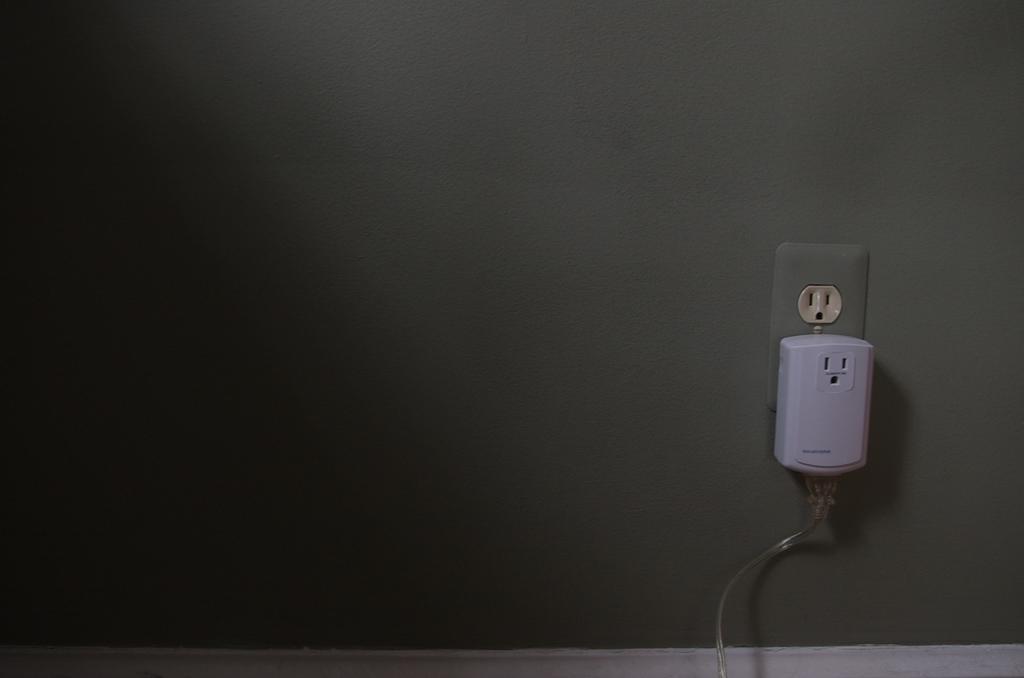Please provide a concise description of this image. In this picture we can see a wall with the sockets and on the socket there is an adapter with a cable. 